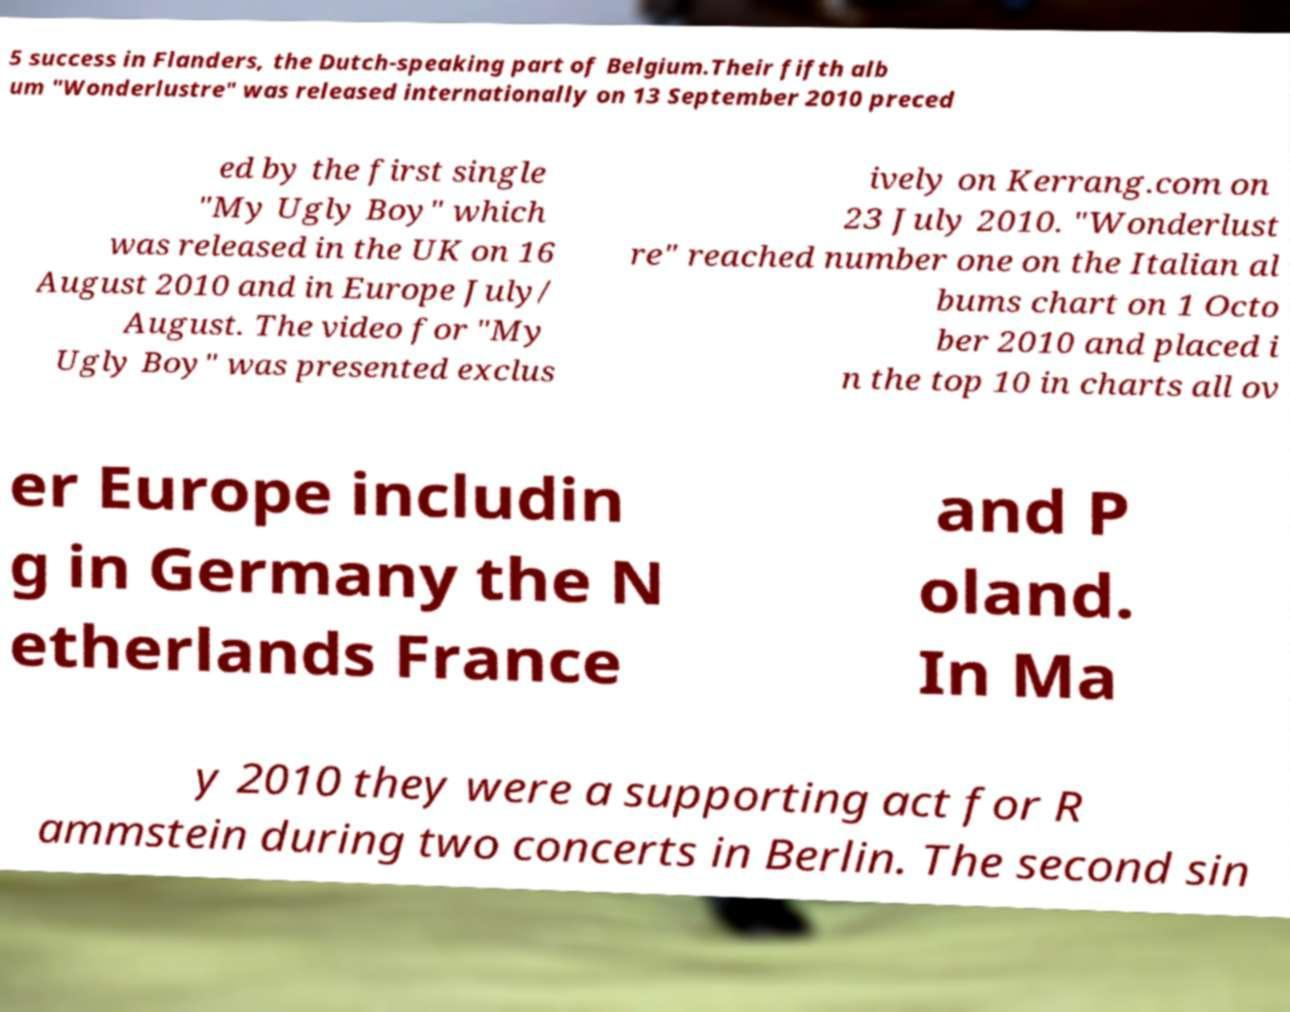Can you read and provide the text displayed in the image?This photo seems to have some interesting text. Can you extract and type it out for me? 5 success in Flanders, the Dutch-speaking part of Belgium.Their fifth alb um "Wonderlustre" was released internationally on 13 September 2010 preced ed by the first single "My Ugly Boy" which was released in the UK on 16 August 2010 and in Europe July/ August. The video for "My Ugly Boy" was presented exclus ively on Kerrang.com on 23 July 2010. "Wonderlust re" reached number one on the Italian al bums chart on 1 Octo ber 2010 and placed i n the top 10 in charts all ov er Europe includin g in Germany the N etherlands France and P oland. In Ma y 2010 they were a supporting act for R ammstein during two concerts in Berlin. The second sin 